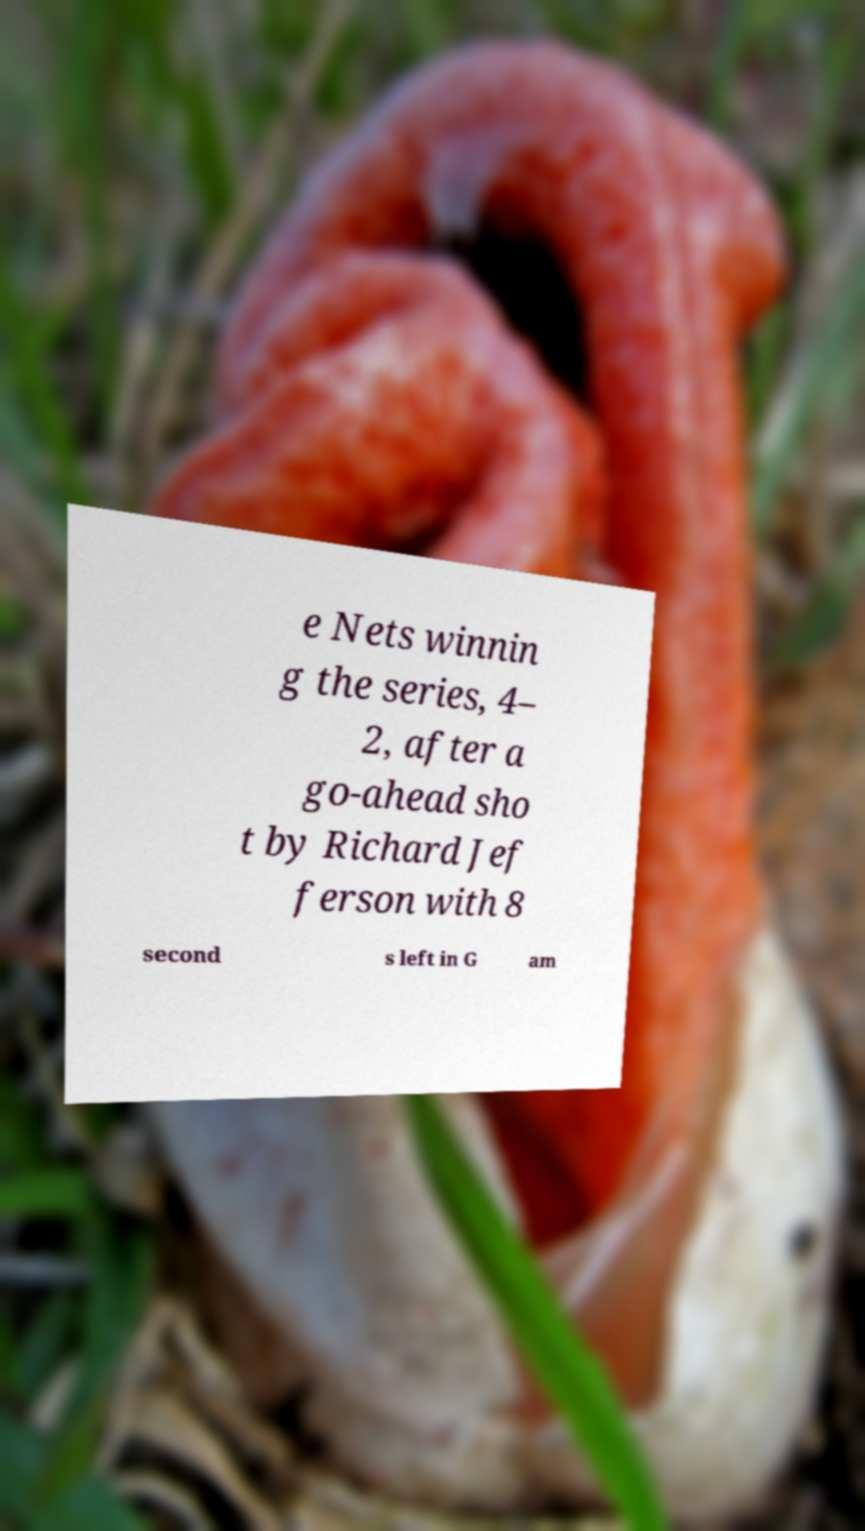There's text embedded in this image that I need extracted. Can you transcribe it verbatim? e Nets winnin g the series, 4– 2, after a go-ahead sho t by Richard Jef ferson with 8 second s left in G am 